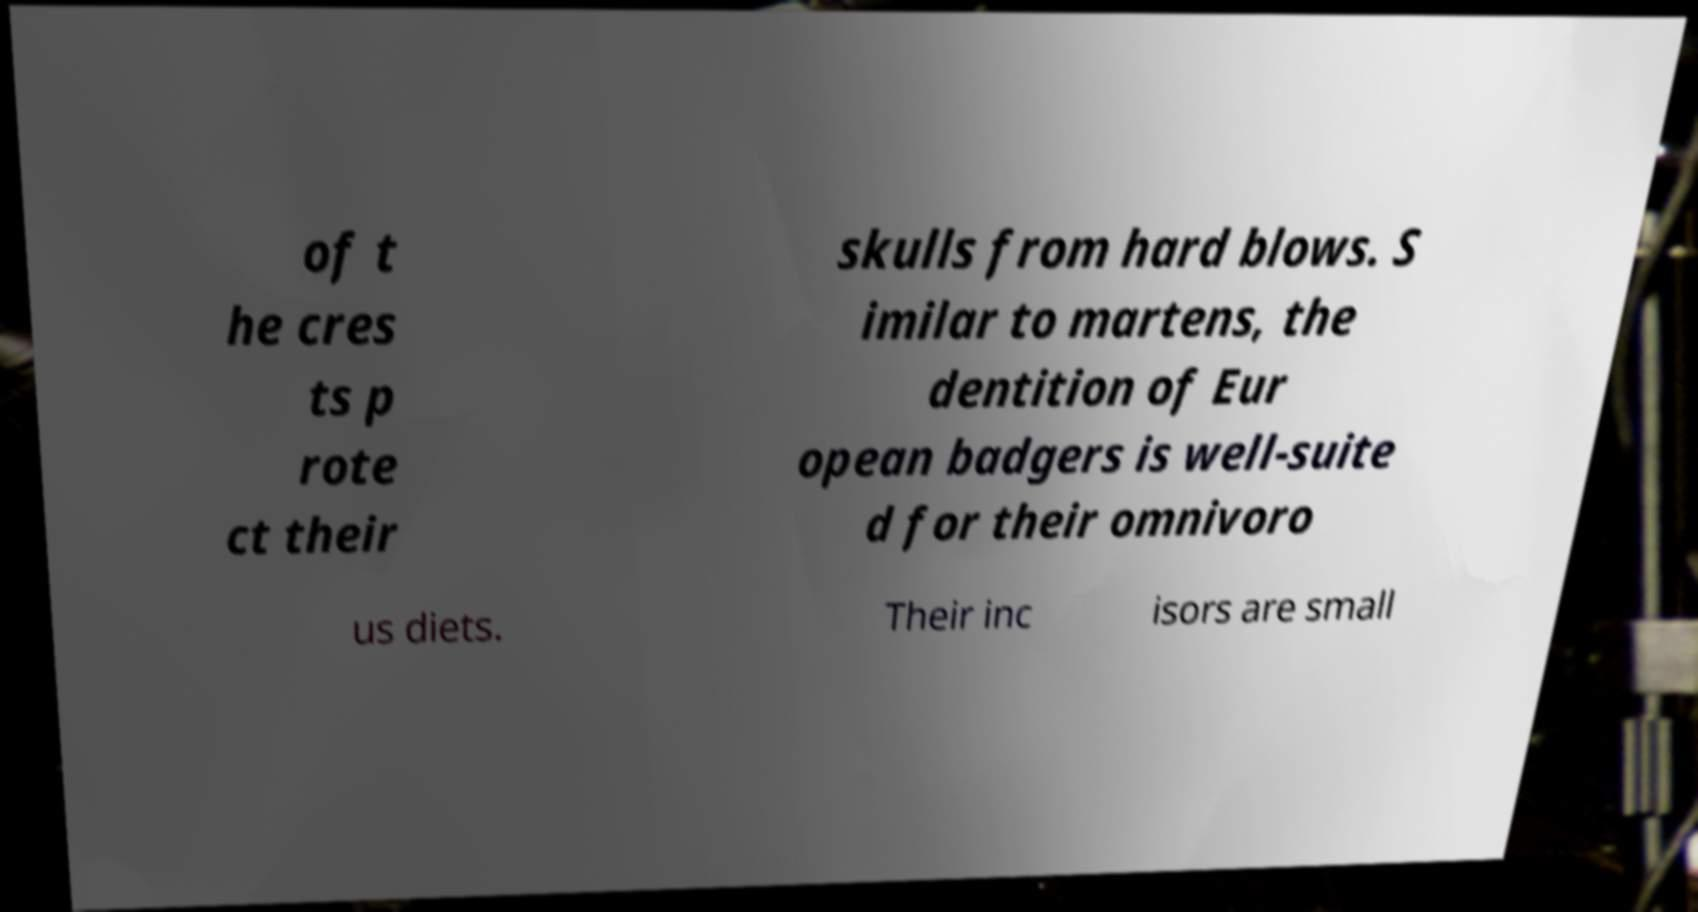Could you extract and type out the text from this image? of t he cres ts p rote ct their skulls from hard blows. S imilar to martens, the dentition of Eur opean badgers is well-suite d for their omnivoro us diets. Their inc isors are small 